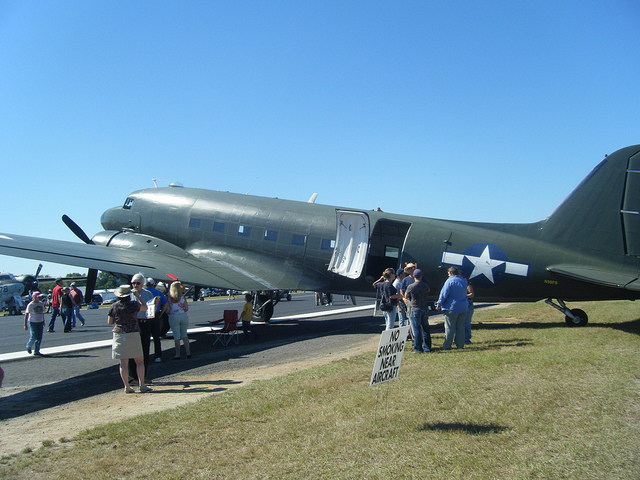Please transcribe the text in this image. SMOKING NEAR AIRCRAFT 